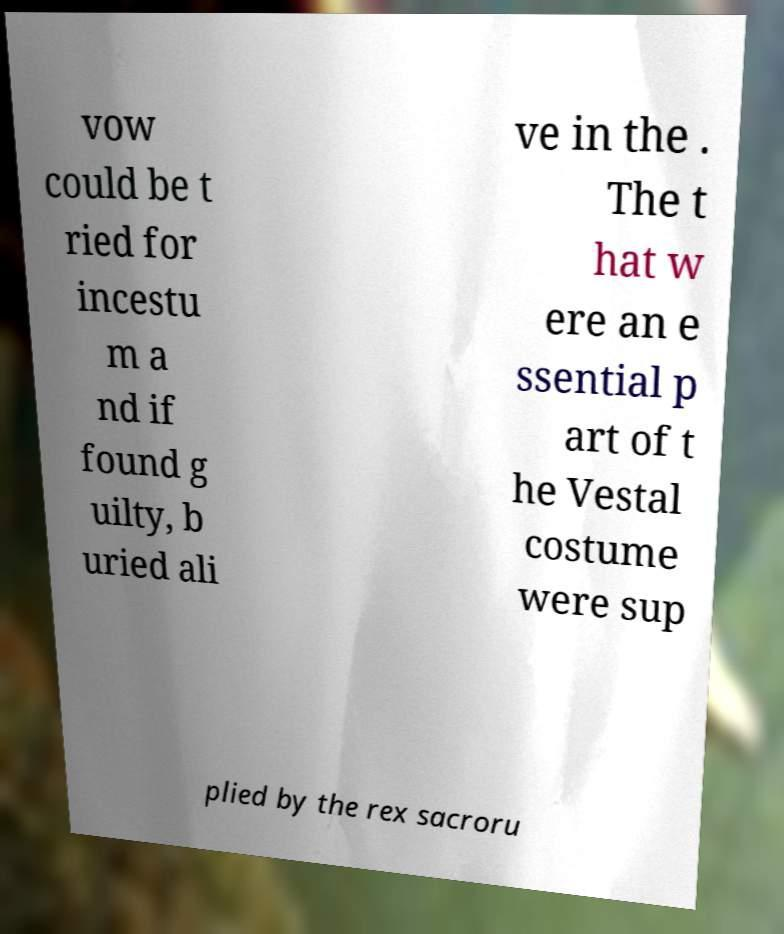Could you extract and type out the text from this image? vow could be t ried for incestu m a nd if found g uilty, b uried ali ve in the . The t hat w ere an e ssential p art of t he Vestal costume were sup plied by the rex sacroru 